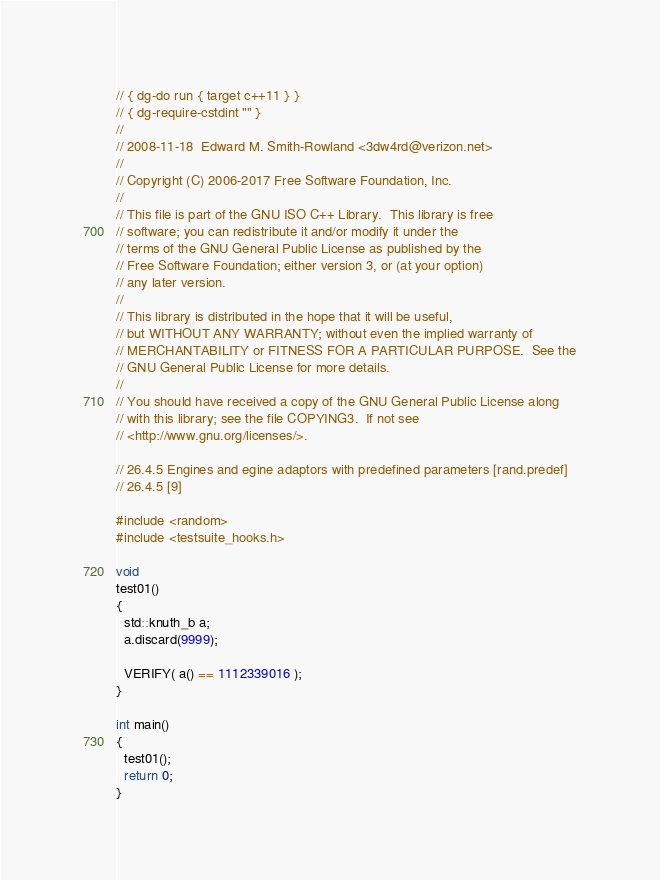Convert code to text. <code><loc_0><loc_0><loc_500><loc_500><_C++_>// { dg-do run { target c++11 } }
// { dg-require-cstdint "" }
//
// 2008-11-18  Edward M. Smith-Rowland <3dw4rd@verizon.net>
//
// Copyright (C) 2006-2017 Free Software Foundation, Inc.
//
// This file is part of the GNU ISO C++ Library.  This library is free
// software; you can redistribute it and/or modify it under the
// terms of the GNU General Public License as published by the
// Free Software Foundation; either version 3, or (at your option)
// any later version.
//
// This library is distributed in the hope that it will be useful,
// but WITHOUT ANY WARRANTY; without even the implied warranty of
// MERCHANTABILITY or FITNESS FOR A PARTICULAR PURPOSE.  See the
// GNU General Public License for more details.
//
// You should have received a copy of the GNU General Public License along
// with this library; see the file COPYING3.  If not see
// <http://www.gnu.org/licenses/>.

// 26.4.5 Engines and egine adaptors with predefined parameters [rand.predef]
// 26.4.5 [9]

#include <random>
#include <testsuite_hooks.h>

void
test01()
{
  std::knuth_b a;
  a.discard(9999);

  VERIFY( a() == 1112339016 );
}

int main()
{
  test01();
  return 0;
}
</code> 